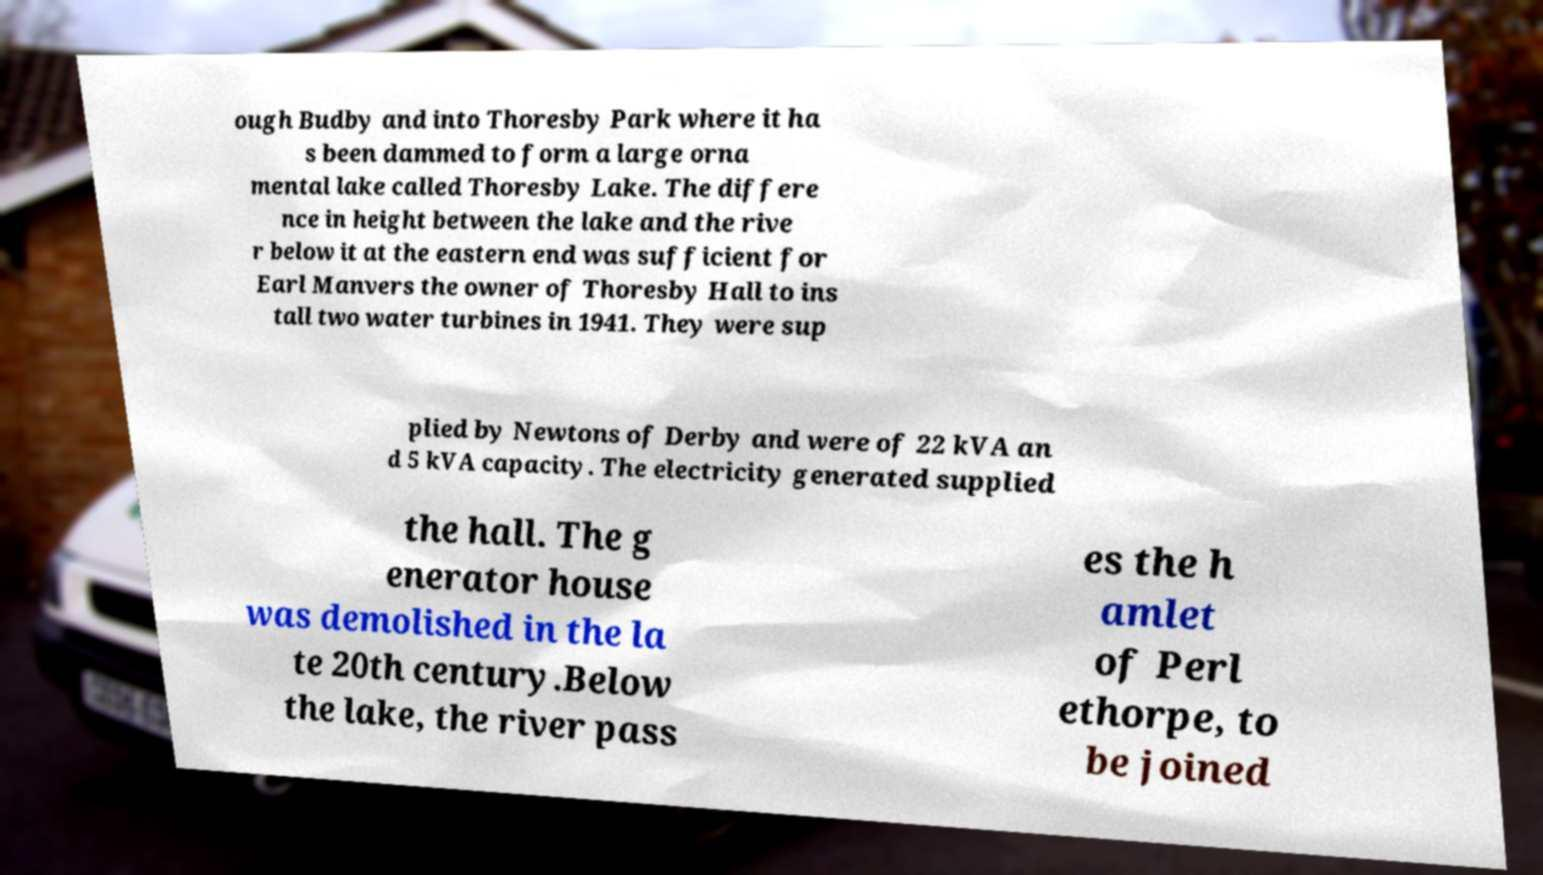Can you read and provide the text displayed in the image?This photo seems to have some interesting text. Can you extract and type it out for me? ough Budby and into Thoresby Park where it ha s been dammed to form a large orna mental lake called Thoresby Lake. The differe nce in height between the lake and the rive r below it at the eastern end was sufficient for Earl Manvers the owner of Thoresby Hall to ins tall two water turbines in 1941. They were sup plied by Newtons of Derby and were of 22 kVA an d 5 kVA capacity. The electricity generated supplied the hall. The g enerator house was demolished in the la te 20th century.Below the lake, the river pass es the h amlet of Perl ethorpe, to be joined 